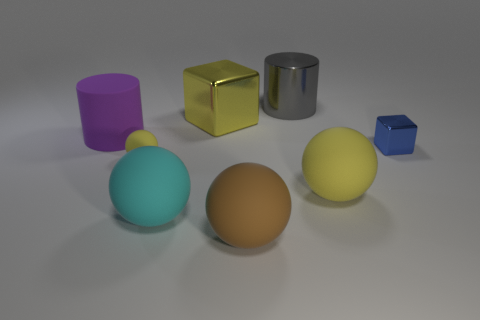Subtract 1 balls. How many balls are left? 3 Add 2 big metal things. How many objects exist? 10 Subtract all blocks. How many objects are left? 6 Add 6 blue metal things. How many blue metal things are left? 7 Add 8 blue metal blocks. How many blue metal blocks exist? 9 Subtract 0 purple cubes. How many objects are left? 8 Subtract all yellow metallic balls. Subtract all big things. How many objects are left? 2 